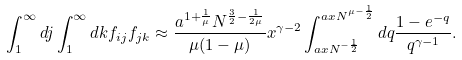<formula> <loc_0><loc_0><loc_500><loc_500>\int _ { 1 } ^ { \infty } d j \int _ { 1 } ^ { \infty } d k f _ { i j } f _ { j k } \approx \frac { a ^ { 1 + \frac { 1 } { \mu } } N ^ { \frac { 3 } { 2 } - \frac { 1 } { 2 \mu } } } { \mu ( 1 - \mu ) } x ^ { \gamma - 2 } \int _ { a x N ^ { - \frac { 1 } { 2 } } } ^ { a x N ^ { \mu - \frac { 1 } { 2 } } } d q \frac { 1 - e ^ { - q } } { q ^ { \gamma - 1 } } .</formula> 